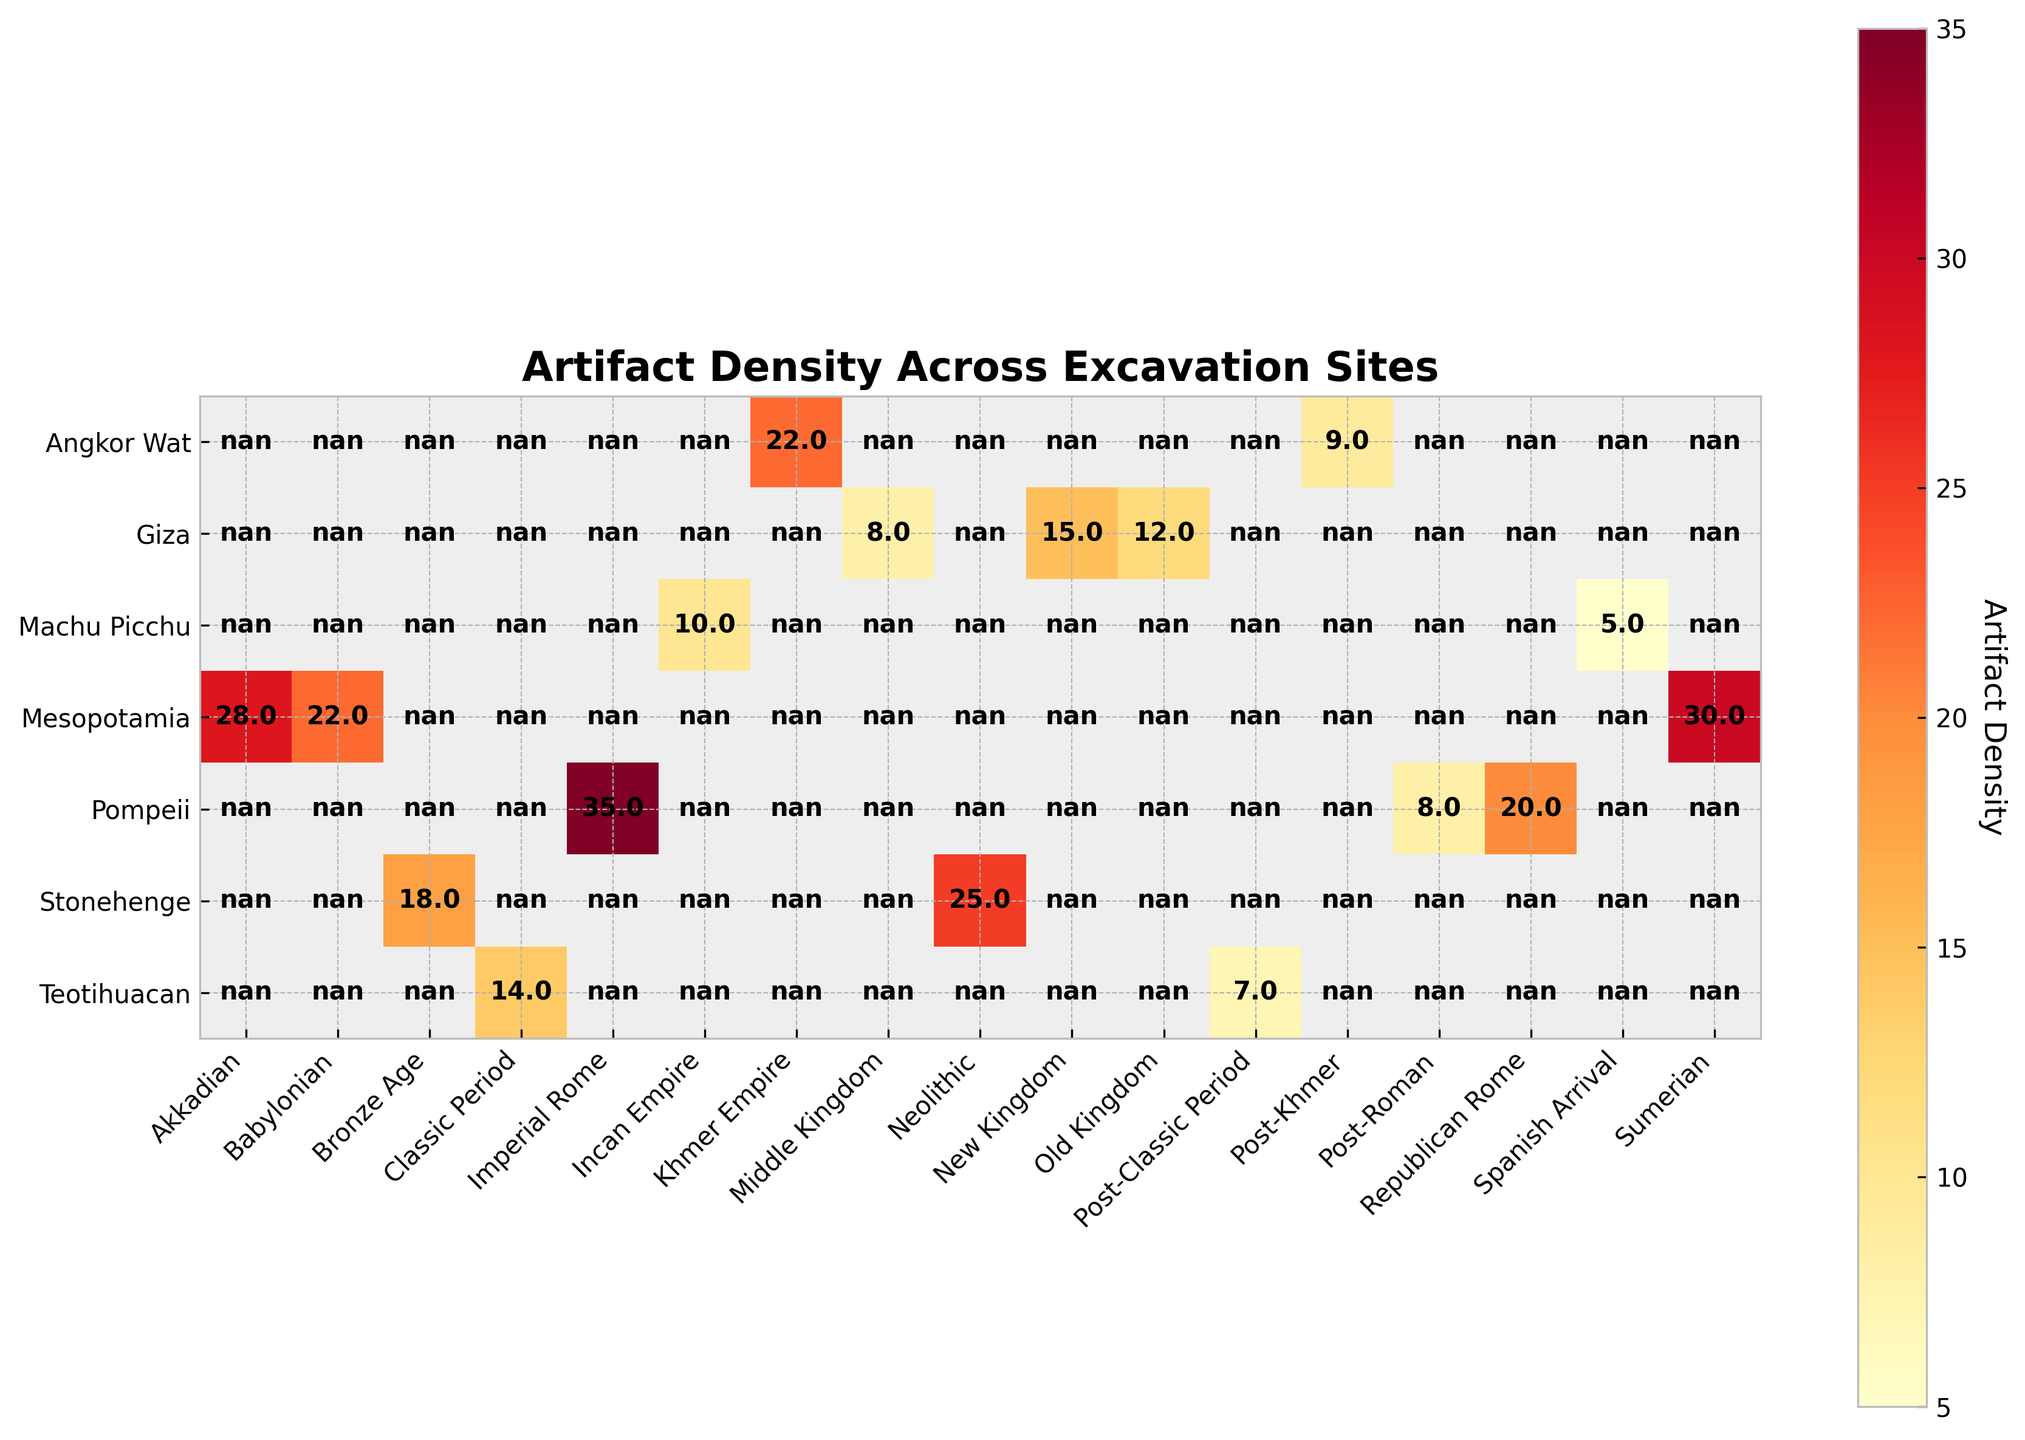What is the title of the figure? The title is typically found at the top of the figure and is meant to provide an overview of what the data depicts. In this case, it should be clear what the figure is about from reading the title.
Answer: "Artifact Density Across Excavation Sites" Which site shows the highest artifact density during the Post-Roman period? Identify the row corresponding to the "Pompeii" site and look at the cell under the "Post-Roman" column to determine its artifact density value.
Answer: Pompeii What is the average artifact density for Giza across all time periods? Locate the row for "Giza" and add up the artifact densities for the Old Kingdom, Middle Kingdom, and New Kingdom periods. Then divide by the number of periods (3) to find the average. Calculation: (12 + 8 + 15) / 3 = 35 / 3.
Answer: 11.67 Which site has the highest artifact density in a single time period, and what is the value? Browse through all the cells in the heatmap, looking for the highest number. Compare across different sites and time periods to find the highest value.
Answer: Pompeii during the Imperial Rome period with a value of 35 Which site has a higher artifact density during the New Kingdom, Giza or Teotihuacan? Compare the artifact density values for the New Kingdom period for both Giza and Teotihuacan by looking at the respective cells in their rows under the same column.
Answer: Giza What is the total artifact density for Mesopotamia across all listed time periods? Find the row corresponding to "Mesopotamia" and sum the artifact densities for the Sumerian, Akkadian, and Babylonian periods. Calculation: 30 + 28 + 22 = 80.
Answer: 80 How does the artifact density at Machu Picchu change from the Incan Empire period to the Spanish Arrival period? Observe the values for the Incan Empire and Spanish Arrival periods in the Machu Picchu row and note the difference. Calculation: 10 (Incan Empire) - 5 (Spanish Arrival) = 5.
Answer: It decreases by 5 Which site has the lowest artifact density in the figure? Scan all the cells in the heatmap for the lowest artifact density value.
Answer: Teotihuacan during the Post-Classic Period with a value of 7 What is the range of artifact densities for Angkor Wat? Identify the highest and lowest artifact densities for Angkor Wat by looking at the values in its row, and then subtract the lowest value from the highest. Calculation: 22 (Khmer Empire) - 9 (Post-Khmer) = 13.
Answer: 13 